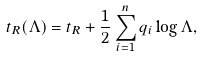<formula> <loc_0><loc_0><loc_500><loc_500>t _ { R } ( \Lambda ) = t _ { R } + \frac { 1 } { 2 } \sum _ { i = 1 } ^ { n } q _ { i } \log \Lambda ,</formula> 